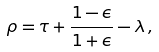Convert formula to latex. <formula><loc_0><loc_0><loc_500><loc_500>\rho = \tau + \frac { 1 - \epsilon } { 1 + \epsilon } - \lambda \, ,</formula> 